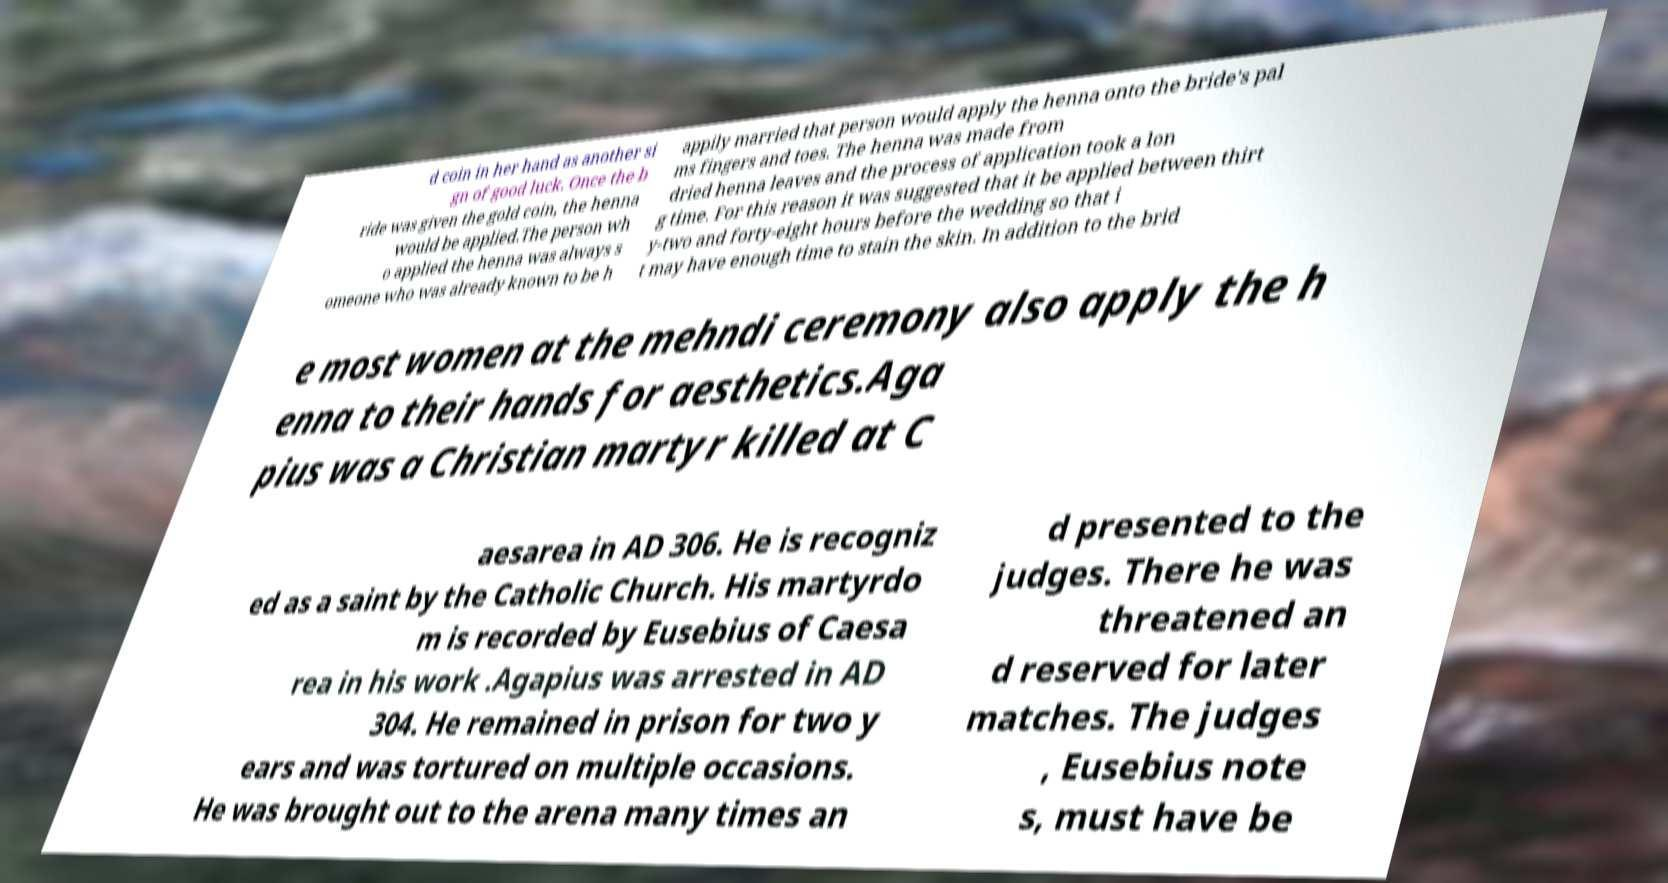Could you assist in decoding the text presented in this image and type it out clearly? d coin in her hand as another si gn of good luck. Once the b ride was given the gold coin, the henna would be applied.The person wh o applied the henna was always s omeone who was already known to be h appily married that person would apply the henna onto the bride's pal ms fingers and toes. The henna was made from dried henna leaves and the process of application took a lon g time. For this reason it was suggested that it be applied between thirt y-two and forty-eight hours before the wedding so that i t may have enough time to stain the skin. In addition to the brid e most women at the mehndi ceremony also apply the h enna to their hands for aesthetics.Aga pius was a Christian martyr killed at C aesarea in AD 306. He is recogniz ed as a saint by the Catholic Church. His martyrdo m is recorded by Eusebius of Caesa rea in his work .Agapius was arrested in AD 304. He remained in prison for two y ears and was tortured on multiple occasions. He was brought out to the arena many times an d presented to the judges. There he was threatened an d reserved for later matches. The judges , Eusebius note s, must have be 